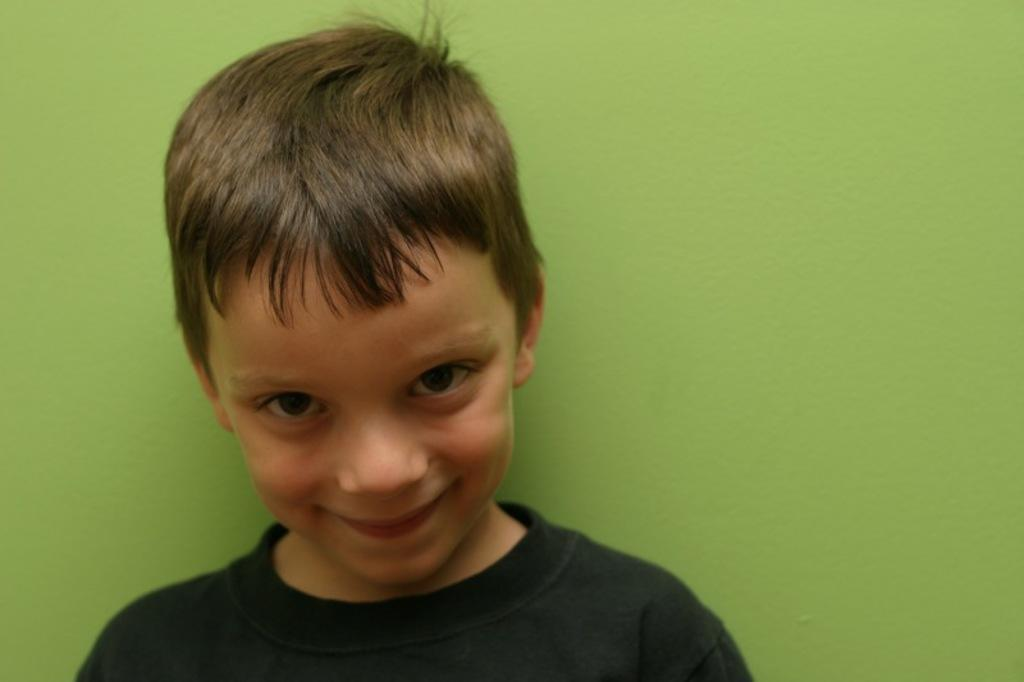Who is the main subject in the image? There is a boy in the image. What is the boy wearing? The boy is wearing a black T-shirt. What can be seen in the background of the image? There is a wall in the background of the image. What color is the wall? The wall is painted green. Are there any birds made of plastic in the image? There are no birds, made of plastic or any other material, present in the image. 